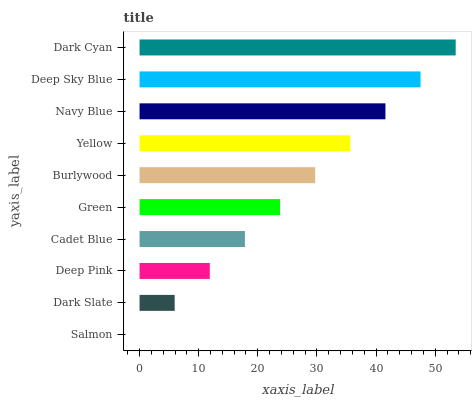Is Salmon the minimum?
Answer yes or no. Yes. Is Dark Cyan the maximum?
Answer yes or no. Yes. Is Dark Slate the minimum?
Answer yes or no. No. Is Dark Slate the maximum?
Answer yes or no. No. Is Dark Slate greater than Salmon?
Answer yes or no. Yes. Is Salmon less than Dark Slate?
Answer yes or no. Yes. Is Salmon greater than Dark Slate?
Answer yes or no. No. Is Dark Slate less than Salmon?
Answer yes or no. No. Is Burlywood the high median?
Answer yes or no. Yes. Is Green the low median?
Answer yes or no. Yes. Is Salmon the high median?
Answer yes or no. No. Is Dark Cyan the low median?
Answer yes or no. No. 